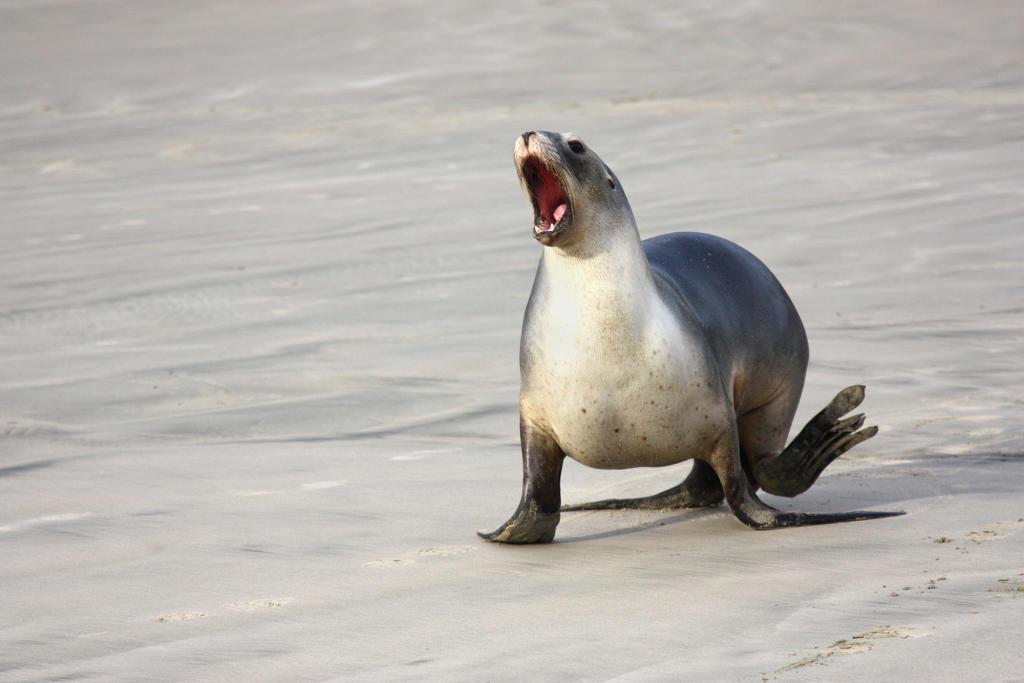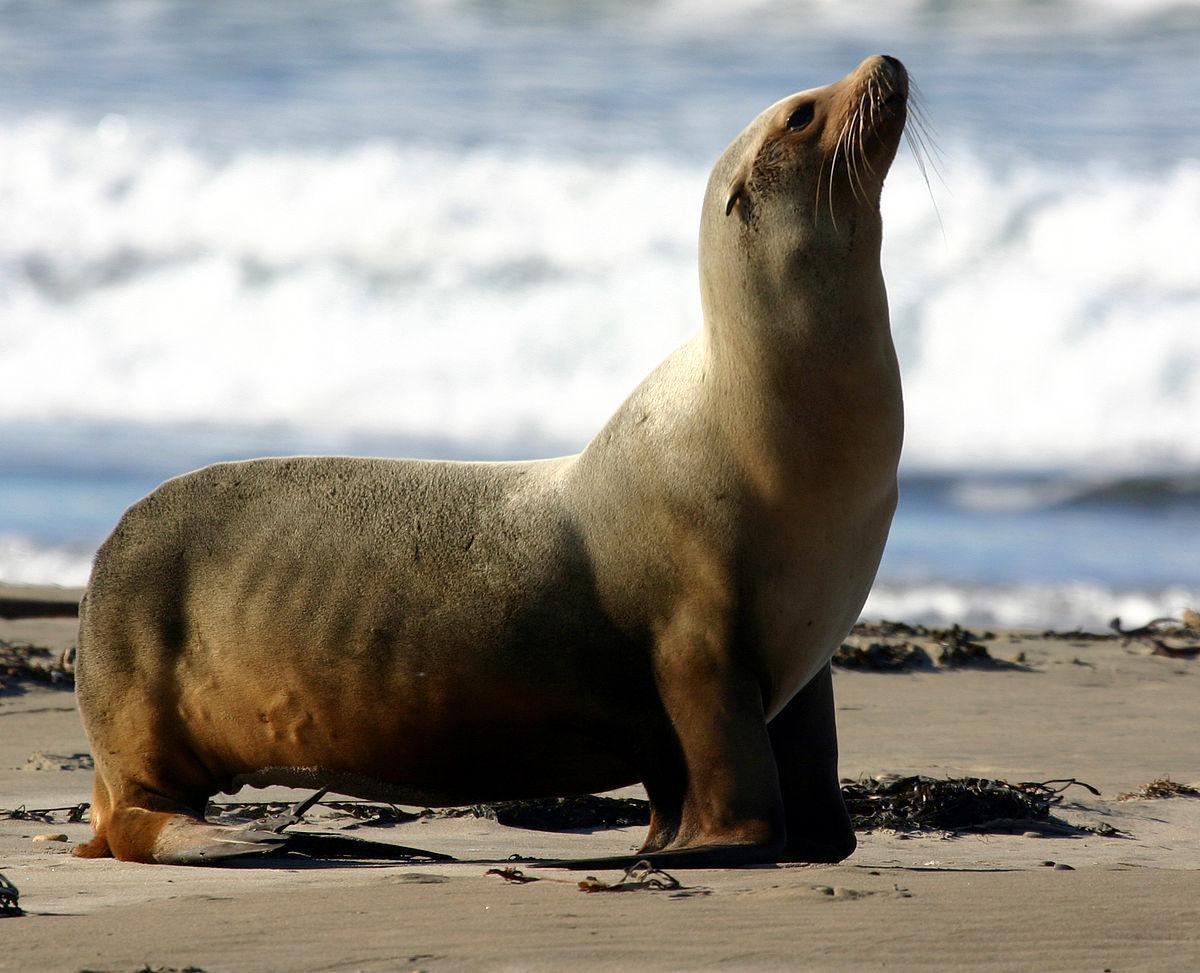The first image is the image on the left, the second image is the image on the right. Assess this claim about the two images: "There is 1 seal near waves on a sunny day.". Correct or not? Answer yes or no. Yes. The first image is the image on the left, the second image is the image on the right. For the images shown, is this caption "There is exactly one seal in the image on the left." true? Answer yes or no. Yes. The first image is the image on the left, the second image is the image on the right. For the images shown, is this caption "An image shows a seal with body in profile and water visible." true? Answer yes or no. Yes. 